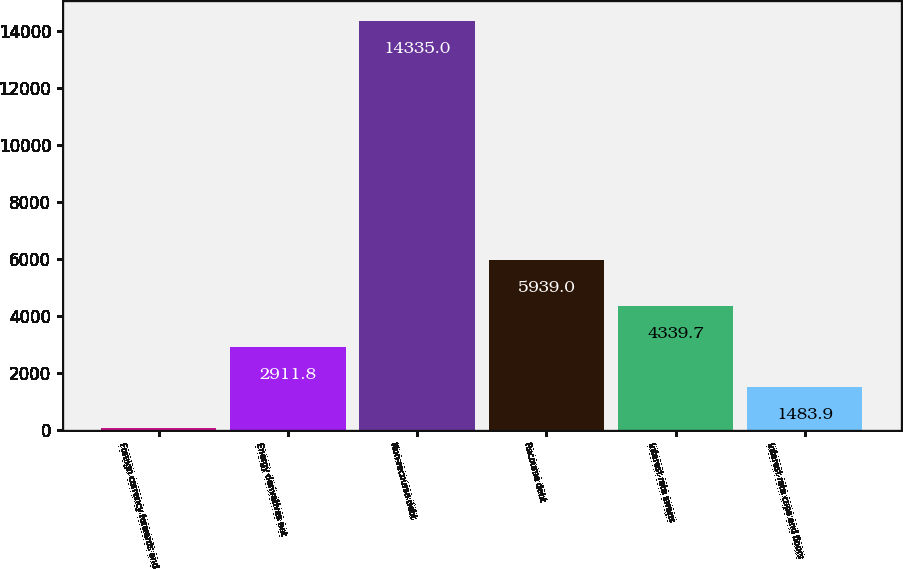Convert chart. <chart><loc_0><loc_0><loc_500><loc_500><bar_chart><fcel>Foreign currency forwards and<fcel>Energy derivatives net<fcel>Non-recourse debt<fcel>Recourse debt<fcel>Interest rate swaps<fcel>Interest rate caps and floors<nl><fcel>56<fcel>2911.8<fcel>14335<fcel>5939<fcel>4339.7<fcel>1483.9<nl></chart> 